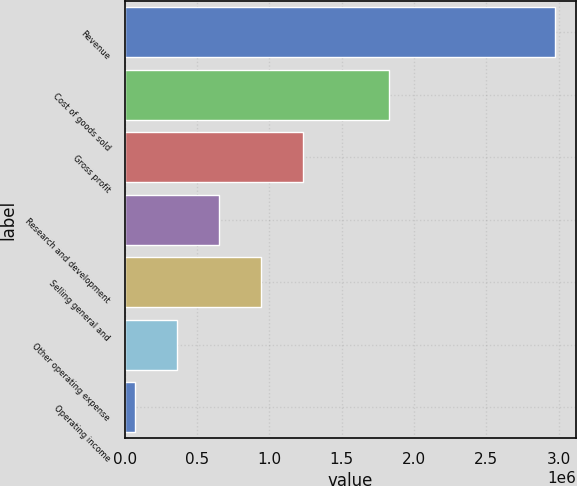<chart> <loc_0><loc_0><loc_500><loc_500><bar_chart><fcel>Revenue<fcel>Cost of goods sold<fcel>Gross profit<fcel>Research and development<fcel>Selling general and<fcel>Other operating expense<fcel>Operating income<nl><fcel>2.97354e+06<fcel>1.82657e+06<fcel>1.23158e+06<fcel>650933<fcel>941258<fcel>360607<fcel>70282<nl></chart> 